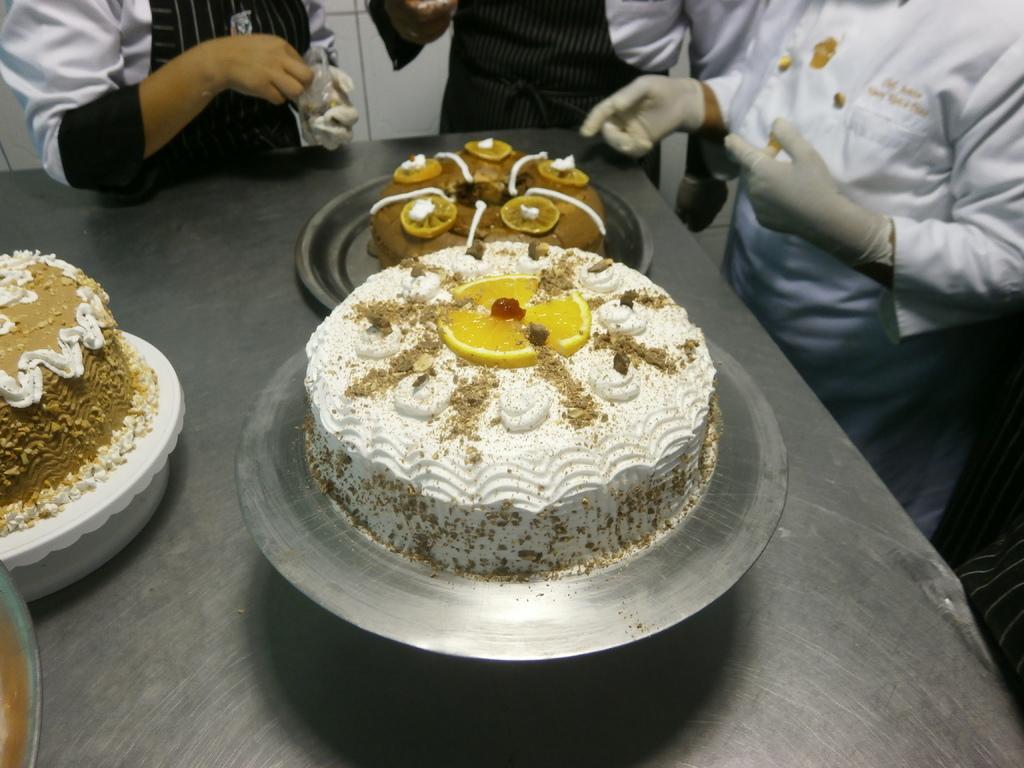Can you describe this image briefly? In this image I can see the plate with food. The food is in brown color. It is on the silver color surface. To the side I can see three people with white and black color dresses. 